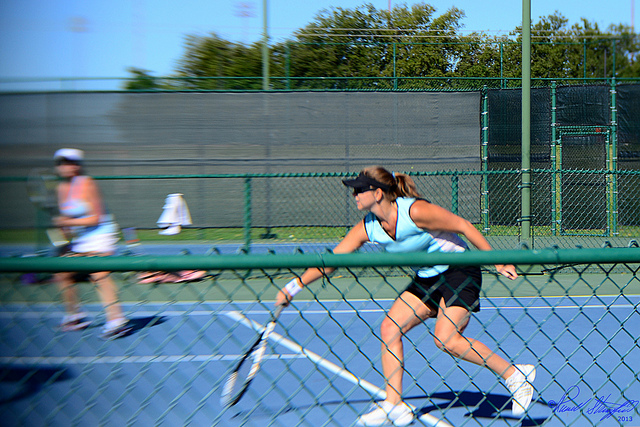What surface are they playing on?
A. clay
B. indoor hard
C. outdoor hard
D. grass The tennis match is being played on an outdoor hard court surface. You can tell by the typical light blue or green coloring and the hard, flat surface that characterizes this type of tennis court. Unlike clay courts, which have a distinctive red or orange color and leave noticeable ball marks, or grass courts, which have a unique texture and color variation due to the natural grass, the court in the image has neither of those characteristics, and it also lacks the enclosed setting of an indoor court. 